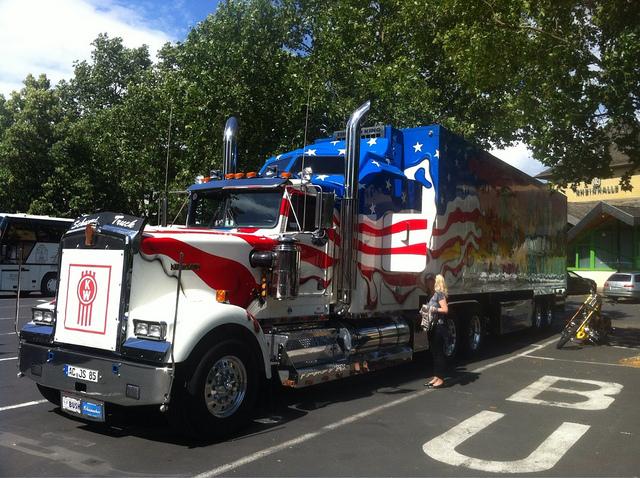Does the truck have a US license plate?
Keep it brief. No. What type of truck is this?
Answer briefly. Semi. What two letters are visible on the parking lot?
Concise answer only. Bu. What flag is represented in the truck design?
Quick response, please. American. Is this truck moving?
Short answer required. No. 